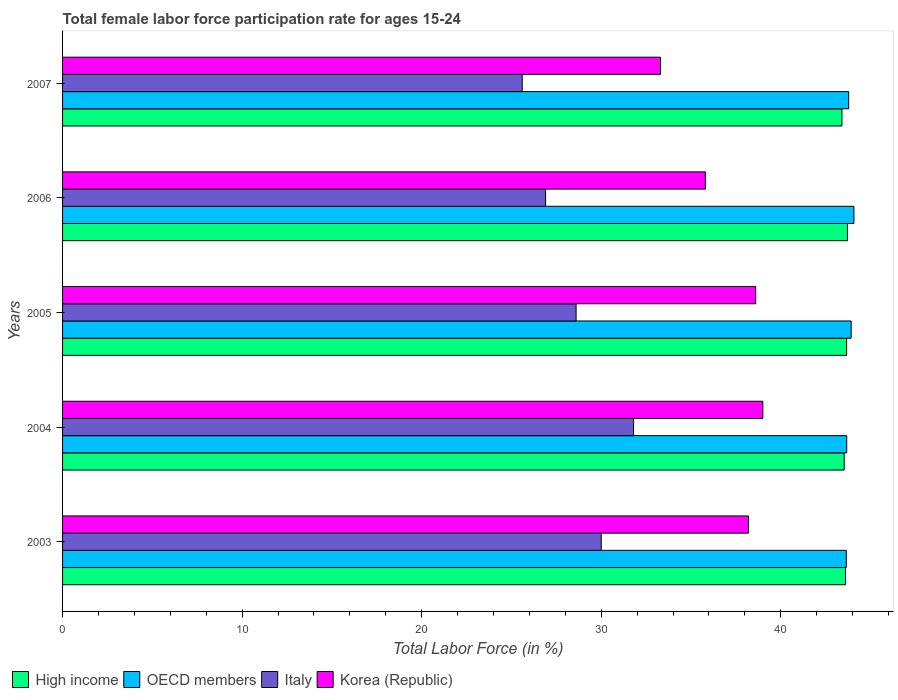How many different coloured bars are there?
Keep it short and to the point. 4. How many groups of bars are there?
Offer a terse response. 5. How many bars are there on the 1st tick from the top?
Provide a succinct answer. 4. How many bars are there on the 2nd tick from the bottom?
Your answer should be compact. 4. What is the label of the 3rd group of bars from the top?
Your answer should be very brief. 2005. What is the female labor force participation rate in Korea (Republic) in 2005?
Offer a very short reply. 38.6. Across all years, what is the maximum female labor force participation rate in Italy?
Your answer should be very brief. 31.8. Across all years, what is the minimum female labor force participation rate in Italy?
Offer a terse response. 25.6. What is the total female labor force participation rate in High income in the graph?
Your answer should be compact. 217.91. What is the difference between the female labor force participation rate in High income in 2004 and that in 2006?
Make the answer very short. -0.18. What is the difference between the female labor force participation rate in Korea (Republic) in 2007 and the female labor force participation rate in High income in 2003?
Give a very brief answer. -10.3. What is the average female labor force participation rate in Italy per year?
Give a very brief answer. 28.58. In the year 2004, what is the difference between the female labor force participation rate in OECD members and female labor force participation rate in Italy?
Your answer should be very brief. 11.87. In how many years, is the female labor force participation rate in Korea (Republic) greater than 6 %?
Your answer should be very brief. 5. What is the ratio of the female labor force participation rate in OECD members in 2003 to that in 2005?
Offer a terse response. 0.99. What is the difference between the highest and the second highest female labor force participation rate in Korea (Republic)?
Your answer should be compact. 0.4. What is the difference between the highest and the lowest female labor force participation rate in OECD members?
Keep it short and to the point. 0.43. Is the sum of the female labor force participation rate in High income in 2004 and 2006 greater than the maximum female labor force participation rate in Italy across all years?
Your answer should be compact. Yes. Is it the case that in every year, the sum of the female labor force participation rate in Korea (Republic) and female labor force participation rate in Italy is greater than the sum of female labor force participation rate in OECD members and female labor force participation rate in High income?
Keep it short and to the point. Yes. How many bars are there?
Keep it short and to the point. 20. Are all the bars in the graph horizontal?
Offer a very short reply. Yes. What is the difference between two consecutive major ticks on the X-axis?
Your answer should be very brief. 10. Are the values on the major ticks of X-axis written in scientific E-notation?
Give a very brief answer. No. Does the graph contain any zero values?
Ensure brevity in your answer.  No. Where does the legend appear in the graph?
Provide a succinct answer. Bottom left. What is the title of the graph?
Your answer should be very brief. Total female labor force participation rate for ages 15-24. Does "Norway" appear as one of the legend labels in the graph?
Give a very brief answer. No. What is the label or title of the X-axis?
Ensure brevity in your answer.  Total Labor Force (in %). What is the label or title of the Y-axis?
Keep it short and to the point. Years. What is the Total Labor Force (in %) in High income in 2003?
Offer a very short reply. 43.6. What is the Total Labor Force (in %) in OECD members in 2003?
Offer a terse response. 43.65. What is the Total Labor Force (in %) of Italy in 2003?
Provide a succinct answer. 30. What is the Total Labor Force (in %) in Korea (Republic) in 2003?
Offer a very short reply. 38.2. What is the Total Labor Force (in %) of High income in 2004?
Keep it short and to the point. 43.53. What is the Total Labor Force (in %) of OECD members in 2004?
Give a very brief answer. 43.67. What is the Total Labor Force (in %) in Italy in 2004?
Offer a very short reply. 31.8. What is the Total Labor Force (in %) of High income in 2005?
Your answer should be very brief. 43.67. What is the Total Labor Force (in %) of OECD members in 2005?
Make the answer very short. 43.92. What is the Total Labor Force (in %) of Italy in 2005?
Keep it short and to the point. 28.6. What is the Total Labor Force (in %) of Korea (Republic) in 2005?
Your response must be concise. 38.6. What is the Total Labor Force (in %) of High income in 2006?
Provide a short and direct response. 43.71. What is the Total Labor Force (in %) of OECD members in 2006?
Give a very brief answer. 44.07. What is the Total Labor Force (in %) of Italy in 2006?
Provide a short and direct response. 26.9. What is the Total Labor Force (in %) in Korea (Republic) in 2006?
Your response must be concise. 35.8. What is the Total Labor Force (in %) of High income in 2007?
Give a very brief answer. 43.41. What is the Total Labor Force (in %) of OECD members in 2007?
Ensure brevity in your answer.  43.78. What is the Total Labor Force (in %) of Italy in 2007?
Keep it short and to the point. 25.6. What is the Total Labor Force (in %) in Korea (Republic) in 2007?
Offer a terse response. 33.3. Across all years, what is the maximum Total Labor Force (in %) of High income?
Make the answer very short. 43.71. Across all years, what is the maximum Total Labor Force (in %) in OECD members?
Your response must be concise. 44.07. Across all years, what is the maximum Total Labor Force (in %) of Italy?
Offer a very short reply. 31.8. Across all years, what is the maximum Total Labor Force (in %) of Korea (Republic)?
Give a very brief answer. 39. Across all years, what is the minimum Total Labor Force (in %) of High income?
Make the answer very short. 43.41. Across all years, what is the minimum Total Labor Force (in %) of OECD members?
Make the answer very short. 43.65. Across all years, what is the minimum Total Labor Force (in %) in Italy?
Provide a succinct answer. 25.6. Across all years, what is the minimum Total Labor Force (in %) of Korea (Republic)?
Make the answer very short. 33.3. What is the total Total Labor Force (in %) in High income in the graph?
Ensure brevity in your answer.  217.91. What is the total Total Labor Force (in %) in OECD members in the graph?
Offer a very short reply. 219.09. What is the total Total Labor Force (in %) in Italy in the graph?
Keep it short and to the point. 142.9. What is the total Total Labor Force (in %) of Korea (Republic) in the graph?
Offer a very short reply. 184.9. What is the difference between the Total Labor Force (in %) of High income in 2003 and that in 2004?
Your answer should be very brief. 0.07. What is the difference between the Total Labor Force (in %) of OECD members in 2003 and that in 2004?
Your answer should be very brief. -0.03. What is the difference between the Total Labor Force (in %) in Italy in 2003 and that in 2004?
Your answer should be compact. -1.8. What is the difference between the Total Labor Force (in %) in Korea (Republic) in 2003 and that in 2004?
Offer a terse response. -0.8. What is the difference between the Total Labor Force (in %) in High income in 2003 and that in 2005?
Ensure brevity in your answer.  -0.07. What is the difference between the Total Labor Force (in %) of OECD members in 2003 and that in 2005?
Provide a succinct answer. -0.27. What is the difference between the Total Labor Force (in %) of Italy in 2003 and that in 2005?
Give a very brief answer. 1.4. What is the difference between the Total Labor Force (in %) of Korea (Republic) in 2003 and that in 2005?
Offer a very short reply. -0.4. What is the difference between the Total Labor Force (in %) in High income in 2003 and that in 2006?
Provide a short and direct response. -0.11. What is the difference between the Total Labor Force (in %) of OECD members in 2003 and that in 2006?
Offer a very short reply. -0.43. What is the difference between the Total Labor Force (in %) in High income in 2003 and that in 2007?
Offer a terse response. 0.19. What is the difference between the Total Labor Force (in %) in OECD members in 2003 and that in 2007?
Offer a very short reply. -0.14. What is the difference between the Total Labor Force (in %) in Italy in 2003 and that in 2007?
Your answer should be compact. 4.4. What is the difference between the Total Labor Force (in %) of Korea (Republic) in 2003 and that in 2007?
Keep it short and to the point. 4.9. What is the difference between the Total Labor Force (in %) of High income in 2004 and that in 2005?
Your response must be concise. -0.13. What is the difference between the Total Labor Force (in %) of OECD members in 2004 and that in 2005?
Your response must be concise. -0.25. What is the difference between the Total Labor Force (in %) in Korea (Republic) in 2004 and that in 2005?
Ensure brevity in your answer.  0.4. What is the difference between the Total Labor Force (in %) in High income in 2004 and that in 2006?
Give a very brief answer. -0.18. What is the difference between the Total Labor Force (in %) in OECD members in 2004 and that in 2006?
Give a very brief answer. -0.4. What is the difference between the Total Labor Force (in %) in Korea (Republic) in 2004 and that in 2006?
Make the answer very short. 3.2. What is the difference between the Total Labor Force (in %) in High income in 2004 and that in 2007?
Your answer should be compact. 0.13. What is the difference between the Total Labor Force (in %) of OECD members in 2004 and that in 2007?
Offer a terse response. -0.11. What is the difference between the Total Labor Force (in %) of Italy in 2004 and that in 2007?
Keep it short and to the point. 6.2. What is the difference between the Total Labor Force (in %) in High income in 2005 and that in 2006?
Your answer should be compact. -0.05. What is the difference between the Total Labor Force (in %) in OECD members in 2005 and that in 2006?
Offer a terse response. -0.15. What is the difference between the Total Labor Force (in %) in Korea (Republic) in 2005 and that in 2006?
Give a very brief answer. 2.8. What is the difference between the Total Labor Force (in %) in High income in 2005 and that in 2007?
Your response must be concise. 0.26. What is the difference between the Total Labor Force (in %) in OECD members in 2005 and that in 2007?
Your response must be concise. 0.14. What is the difference between the Total Labor Force (in %) in High income in 2006 and that in 2007?
Offer a very short reply. 0.31. What is the difference between the Total Labor Force (in %) of OECD members in 2006 and that in 2007?
Your answer should be compact. 0.29. What is the difference between the Total Labor Force (in %) of Korea (Republic) in 2006 and that in 2007?
Provide a succinct answer. 2.5. What is the difference between the Total Labor Force (in %) in High income in 2003 and the Total Labor Force (in %) in OECD members in 2004?
Offer a terse response. -0.07. What is the difference between the Total Labor Force (in %) of High income in 2003 and the Total Labor Force (in %) of Italy in 2004?
Offer a very short reply. 11.8. What is the difference between the Total Labor Force (in %) in High income in 2003 and the Total Labor Force (in %) in Korea (Republic) in 2004?
Your answer should be compact. 4.6. What is the difference between the Total Labor Force (in %) of OECD members in 2003 and the Total Labor Force (in %) of Italy in 2004?
Your answer should be very brief. 11.85. What is the difference between the Total Labor Force (in %) of OECD members in 2003 and the Total Labor Force (in %) of Korea (Republic) in 2004?
Your answer should be compact. 4.65. What is the difference between the Total Labor Force (in %) of Italy in 2003 and the Total Labor Force (in %) of Korea (Republic) in 2004?
Offer a very short reply. -9. What is the difference between the Total Labor Force (in %) of High income in 2003 and the Total Labor Force (in %) of OECD members in 2005?
Provide a short and direct response. -0.32. What is the difference between the Total Labor Force (in %) in High income in 2003 and the Total Labor Force (in %) in Italy in 2005?
Give a very brief answer. 15. What is the difference between the Total Labor Force (in %) of High income in 2003 and the Total Labor Force (in %) of Korea (Republic) in 2005?
Make the answer very short. 5. What is the difference between the Total Labor Force (in %) in OECD members in 2003 and the Total Labor Force (in %) in Italy in 2005?
Your response must be concise. 15.05. What is the difference between the Total Labor Force (in %) in OECD members in 2003 and the Total Labor Force (in %) in Korea (Republic) in 2005?
Your answer should be compact. 5.05. What is the difference between the Total Labor Force (in %) in Italy in 2003 and the Total Labor Force (in %) in Korea (Republic) in 2005?
Your answer should be very brief. -8.6. What is the difference between the Total Labor Force (in %) in High income in 2003 and the Total Labor Force (in %) in OECD members in 2006?
Your answer should be compact. -0.47. What is the difference between the Total Labor Force (in %) in High income in 2003 and the Total Labor Force (in %) in Italy in 2006?
Provide a succinct answer. 16.7. What is the difference between the Total Labor Force (in %) of High income in 2003 and the Total Labor Force (in %) of Korea (Republic) in 2006?
Make the answer very short. 7.8. What is the difference between the Total Labor Force (in %) of OECD members in 2003 and the Total Labor Force (in %) of Italy in 2006?
Give a very brief answer. 16.75. What is the difference between the Total Labor Force (in %) of OECD members in 2003 and the Total Labor Force (in %) of Korea (Republic) in 2006?
Offer a very short reply. 7.85. What is the difference between the Total Labor Force (in %) in High income in 2003 and the Total Labor Force (in %) in OECD members in 2007?
Your response must be concise. -0.18. What is the difference between the Total Labor Force (in %) of High income in 2003 and the Total Labor Force (in %) of Italy in 2007?
Give a very brief answer. 18. What is the difference between the Total Labor Force (in %) in High income in 2003 and the Total Labor Force (in %) in Korea (Republic) in 2007?
Your answer should be very brief. 10.3. What is the difference between the Total Labor Force (in %) in OECD members in 2003 and the Total Labor Force (in %) in Italy in 2007?
Provide a succinct answer. 18.05. What is the difference between the Total Labor Force (in %) of OECD members in 2003 and the Total Labor Force (in %) of Korea (Republic) in 2007?
Give a very brief answer. 10.35. What is the difference between the Total Labor Force (in %) of Italy in 2003 and the Total Labor Force (in %) of Korea (Republic) in 2007?
Provide a short and direct response. -3.3. What is the difference between the Total Labor Force (in %) in High income in 2004 and the Total Labor Force (in %) in OECD members in 2005?
Offer a terse response. -0.39. What is the difference between the Total Labor Force (in %) of High income in 2004 and the Total Labor Force (in %) of Italy in 2005?
Keep it short and to the point. 14.93. What is the difference between the Total Labor Force (in %) in High income in 2004 and the Total Labor Force (in %) in Korea (Republic) in 2005?
Your answer should be very brief. 4.93. What is the difference between the Total Labor Force (in %) of OECD members in 2004 and the Total Labor Force (in %) of Italy in 2005?
Offer a very short reply. 15.07. What is the difference between the Total Labor Force (in %) in OECD members in 2004 and the Total Labor Force (in %) in Korea (Republic) in 2005?
Keep it short and to the point. 5.07. What is the difference between the Total Labor Force (in %) of High income in 2004 and the Total Labor Force (in %) of OECD members in 2006?
Keep it short and to the point. -0.54. What is the difference between the Total Labor Force (in %) of High income in 2004 and the Total Labor Force (in %) of Italy in 2006?
Give a very brief answer. 16.63. What is the difference between the Total Labor Force (in %) of High income in 2004 and the Total Labor Force (in %) of Korea (Republic) in 2006?
Ensure brevity in your answer.  7.73. What is the difference between the Total Labor Force (in %) of OECD members in 2004 and the Total Labor Force (in %) of Italy in 2006?
Give a very brief answer. 16.77. What is the difference between the Total Labor Force (in %) in OECD members in 2004 and the Total Labor Force (in %) in Korea (Republic) in 2006?
Your response must be concise. 7.87. What is the difference between the Total Labor Force (in %) in Italy in 2004 and the Total Labor Force (in %) in Korea (Republic) in 2006?
Your response must be concise. -4. What is the difference between the Total Labor Force (in %) in High income in 2004 and the Total Labor Force (in %) in OECD members in 2007?
Make the answer very short. -0.25. What is the difference between the Total Labor Force (in %) of High income in 2004 and the Total Labor Force (in %) of Italy in 2007?
Make the answer very short. 17.93. What is the difference between the Total Labor Force (in %) in High income in 2004 and the Total Labor Force (in %) in Korea (Republic) in 2007?
Provide a succinct answer. 10.23. What is the difference between the Total Labor Force (in %) of OECD members in 2004 and the Total Labor Force (in %) of Italy in 2007?
Offer a very short reply. 18.07. What is the difference between the Total Labor Force (in %) in OECD members in 2004 and the Total Labor Force (in %) in Korea (Republic) in 2007?
Give a very brief answer. 10.37. What is the difference between the Total Labor Force (in %) in Italy in 2004 and the Total Labor Force (in %) in Korea (Republic) in 2007?
Your answer should be compact. -1.5. What is the difference between the Total Labor Force (in %) in High income in 2005 and the Total Labor Force (in %) in OECD members in 2006?
Ensure brevity in your answer.  -0.41. What is the difference between the Total Labor Force (in %) of High income in 2005 and the Total Labor Force (in %) of Italy in 2006?
Keep it short and to the point. 16.77. What is the difference between the Total Labor Force (in %) in High income in 2005 and the Total Labor Force (in %) in Korea (Republic) in 2006?
Offer a terse response. 7.87. What is the difference between the Total Labor Force (in %) of OECD members in 2005 and the Total Labor Force (in %) of Italy in 2006?
Give a very brief answer. 17.02. What is the difference between the Total Labor Force (in %) in OECD members in 2005 and the Total Labor Force (in %) in Korea (Republic) in 2006?
Make the answer very short. 8.12. What is the difference between the Total Labor Force (in %) in High income in 2005 and the Total Labor Force (in %) in OECD members in 2007?
Your answer should be compact. -0.12. What is the difference between the Total Labor Force (in %) of High income in 2005 and the Total Labor Force (in %) of Italy in 2007?
Ensure brevity in your answer.  18.07. What is the difference between the Total Labor Force (in %) in High income in 2005 and the Total Labor Force (in %) in Korea (Republic) in 2007?
Your answer should be very brief. 10.37. What is the difference between the Total Labor Force (in %) in OECD members in 2005 and the Total Labor Force (in %) in Italy in 2007?
Offer a very short reply. 18.32. What is the difference between the Total Labor Force (in %) in OECD members in 2005 and the Total Labor Force (in %) in Korea (Republic) in 2007?
Your response must be concise. 10.62. What is the difference between the Total Labor Force (in %) of Italy in 2005 and the Total Labor Force (in %) of Korea (Republic) in 2007?
Offer a terse response. -4.7. What is the difference between the Total Labor Force (in %) of High income in 2006 and the Total Labor Force (in %) of OECD members in 2007?
Provide a short and direct response. -0.07. What is the difference between the Total Labor Force (in %) of High income in 2006 and the Total Labor Force (in %) of Italy in 2007?
Provide a succinct answer. 18.11. What is the difference between the Total Labor Force (in %) in High income in 2006 and the Total Labor Force (in %) in Korea (Republic) in 2007?
Offer a very short reply. 10.41. What is the difference between the Total Labor Force (in %) in OECD members in 2006 and the Total Labor Force (in %) in Italy in 2007?
Offer a terse response. 18.47. What is the difference between the Total Labor Force (in %) in OECD members in 2006 and the Total Labor Force (in %) in Korea (Republic) in 2007?
Ensure brevity in your answer.  10.77. What is the difference between the Total Labor Force (in %) of Italy in 2006 and the Total Labor Force (in %) of Korea (Republic) in 2007?
Provide a short and direct response. -6.4. What is the average Total Labor Force (in %) in High income per year?
Your response must be concise. 43.58. What is the average Total Labor Force (in %) in OECD members per year?
Offer a terse response. 43.82. What is the average Total Labor Force (in %) in Italy per year?
Ensure brevity in your answer.  28.58. What is the average Total Labor Force (in %) of Korea (Republic) per year?
Offer a terse response. 36.98. In the year 2003, what is the difference between the Total Labor Force (in %) in High income and Total Labor Force (in %) in OECD members?
Give a very brief answer. -0.05. In the year 2003, what is the difference between the Total Labor Force (in %) in High income and Total Labor Force (in %) in Italy?
Your response must be concise. 13.6. In the year 2003, what is the difference between the Total Labor Force (in %) of High income and Total Labor Force (in %) of Korea (Republic)?
Give a very brief answer. 5.4. In the year 2003, what is the difference between the Total Labor Force (in %) of OECD members and Total Labor Force (in %) of Italy?
Give a very brief answer. 13.65. In the year 2003, what is the difference between the Total Labor Force (in %) in OECD members and Total Labor Force (in %) in Korea (Republic)?
Offer a very short reply. 5.45. In the year 2004, what is the difference between the Total Labor Force (in %) in High income and Total Labor Force (in %) in OECD members?
Give a very brief answer. -0.14. In the year 2004, what is the difference between the Total Labor Force (in %) in High income and Total Labor Force (in %) in Italy?
Make the answer very short. 11.73. In the year 2004, what is the difference between the Total Labor Force (in %) in High income and Total Labor Force (in %) in Korea (Republic)?
Keep it short and to the point. 4.53. In the year 2004, what is the difference between the Total Labor Force (in %) of OECD members and Total Labor Force (in %) of Italy?
Your answer should be compact. 11.87. In the year 2004, what is the difference between the Total Labor Force (in %) of OECD members and Total Labor Force (in %) of Korea (Republic)?
Offer a very short reply. 4.67. In the year 2005, what is the difference between the Total Labor Force (in %) in High income and Total Labor Force (in %) in OECD members?
Provide a short and direct response. -0.25. In the year 2005, what is the difference between the Total Labor Force (in %) of High income and Total Labor Force (in %) of Italy?
Keep it short and to the point. 15.07. In the year 2005, what is the difference between the Total Labor Force (in %) in High income and Total Labor Force (in %) in Korea (Republic)?
Your answer should be compact. 5.07. In the year 2005, what is the difference between the Total Labor Force (in %) of OECD members and Total Labor Force (in %) of Italy?
Make the answer very short. 15.32. In the year 2005, what is the difference between the Total Labor Force (in %) in OECD members and Total Labor Force (in %) in Korea (Republic)?
Your answer should be compact. 5.32. In the year 2006, what is the difference between the Total Labor Force (in %) of High income and Total Labor Force (in %) of OECD members?
Keep it short and to the point. -0.36. In the year 2006, what is the difference between the Total Labor Force (in %) in High income and Total Labor Force (in %) in Italy?
Keep it short and to the point. 16.81. In the year 2006, what is the difference between the Total Labor Force (in %) in High income and Total Labor Force (in %) in Korea (Republic)?
Your answer should be very brief. 7.91. In the year 2006, what is the difference between the Total Labor Force (in %) in OECD members and Total Labor Force (in %) in Italy?
Keep it short and to the point. 17.17. In the year 2006, what is the difference between the Total Labor Force (in %) of OECD members and Total Labor Force (in %) of Korea (Republic)?
Your response must be concise. 8.27. In the year 2007, what is the difference between the Total Labor Force (in %) in High income and Total Labor Force (in %) in OECD members?
Offer a terse response. -0.38. In the year 2007, what is the difference between the Total Labor Force (in %) in High income and Total Labor Force (in %) in Italy?
Provide a succinct answer. 17.81. In the year 2007, what is the difference between the Total Labor Force (in %) of High income and Total Labor Force (in %) of Korea (Republic)?
Make the answer very short. 10.11. In the year 2007, what is the difference between the Total Labor Force (in %) in OECD members and Total Labor Force (in %) in Italy?
Your answer should be very brief. 18.18. In the year 2007, what is the difference between the Total Labor Force (in %) of OECD members and Total Labor Force (in %) of Korea (Republic)?
Your answer should be compact. 10.48. In the year 2007, what is the difference between the Total Labor Force (in %) in Italy and Total Labor Force (in %) in Korea (Republic)?
Your answer should be compact. -7.7. What is the ratio of the Total Labor Force (in %) in High income in 2003 to that in 2004?
Ensure brevity in your answer.  1. What is the ratio of the Total Labor Force (in %) of Italy in 2003 to that in 2004?
Give a very brief answer. 0.94. What is the ratio of the Total Labor Force (in %) of Korea (Republic) in 2003 to that in 2004?
Give a very brief answer. 0.98. What is the ratio of the Total Labor Force (in %) of High income in 2003 to that in 2005?
Ensure brevity in your answer.  1. What is the ratio of the Total Labor Force (in %) in OECD members in 2003 to that in 2005?
Make the answer very short. 0.99. What is the ratio of the Total Labor Force (in %) in Italy in 2003 to that in 2005?
Your response must be concise. 1.05. What is the ratio of the Total Labor Force (in %) of High income in 2003 to that in 2006?
Your answer should be very brief. 1. What is the ratio of the Total Labor Force (in %) in OECD members in 2003 to that in 2006?
Offer a very short reply. 0.99. What is the ratio of the Total Labor Force (in %) in Italy in 2003 to that in 2006?
Your response must be concise. 1.12. What is the ratio of the Total Labor Force (in %) in Korea (Republic) in 2003 to that in 2006?
Your answer should be compact. 1.07. What is the ratio of the Total Labor Force (in %) of High income in 2003 to that in 2007?
Offer a terse response. 1. What is the ratio of the Total Labor Force (in %) of Italy in 2003 to that in 2007?
Provide a succinct answer. 1.17. What is the ratio of the Total Labor Force (in %) of Korea (Republic) in 2003 to that in 2007?
Ensure brevity in your answer.  1.15. What is the ratio of the Total Labor Force (in %) of OECD members in 2004 to that in 2005?
Make the answer very short. 0.99. What is the ratio of the Total Labor Force (in %) in Italy in 2004 to that in 2005?
Provide a succinct answer. 1.11. What is the ratio of the Total Labor Force (in %) in Korea (Republic) in 2004 to that in 2005?
Give a very brief answer. 1.01. What is the ratio of the Total Labor Force (in %) in OECD members in 2004 to that in 2006?
Your answer should be compact. 0.99. What is the ratio of the Total Labor Force (in %) in Italy in 2004 to that in 2006?
Provide a succinct answer. 1.18. What is the ratio of the Total Labor Force (in %) in Korea (Republic) in 2004 to that in 2006?
Keep it short and to the point. 1.09. What is the ratio of the Total Labor Force (in %) in Italy in 2004 to that in 2007?
Offer a terse response. 1.24. What is the ratio of the Total Labor Force (in %) of Korea (Republic) in 2004 to that in 2007?
Give a very brief answer. 1.17. What is the ratio of the Total Labor Force (in %) of Italy in 2005 to that in 2006?
Provide a short and direct response. 1.06. What is the ratio of the Total Labor Force (in %) of Korea (Republic) in 2005 to that in 2006?
Make the answer very short. 1.08. What is the ratio of the Total Labor Force (in %) in High income in 2005 to that in 2007?
Your response must be concise. 1.01. What is the ratio of the Total Labor Force (in %) in Italy in 2005 to that in 2007?
Your answer should be compact. 1.12. What is the ratio of the Total Labor Force (in %) of Korea (Republic) in 2005 to that in 2007?
Offer a very short reply. 1.16. What is the ratio of the Total Labor Force (in %) in High income in 2006 to that in 2007?
Offer a terse response. 1.01. What is the ratio of the Total Labor Force (in %) in OECD members in 2006 to that in 2007?
Your response must be concise. 1.01. What is the ratio of the Total Labor Force (in %) of Italy in 2006 to that in 2007?
Offer a very short reply. 1.05. What is the ratio of the Total Labor Force (in %) in Korea (Republic) in 2006 to that in 2007?
Your answer should be very brief. 1.08. What is the difference between the highest and the second highest Total Labor Force (in %) of High income?
Ensure brevity in your answer.  0.05. What is the difference between the highest and the second highest Total Labor Force (in %) of OECD members?
Give a very brief answer. 0.15. What is the difference between the highest and the second highest Total Labor Force (in %) in Korea (Republic)?
Your answer should be very brief. 0.4. What is the difference between the highest and the lowest Total Labor Force (in %) of High income?
Ensure brevity in your answer.  0.31. What is the difference between the highest and the lowest Total Labor Force (in %) of OECD members?
Keep it short and to the point. 0.43. What is the difference between the highest and the lowest Total Labor Force (in %) in Italy?
Offer a terse response. 6.2. What is the difference between the highest and the lowest Total Labor Force (in %) of Korea (Republic)?
Your response must be concise. 5.7. 